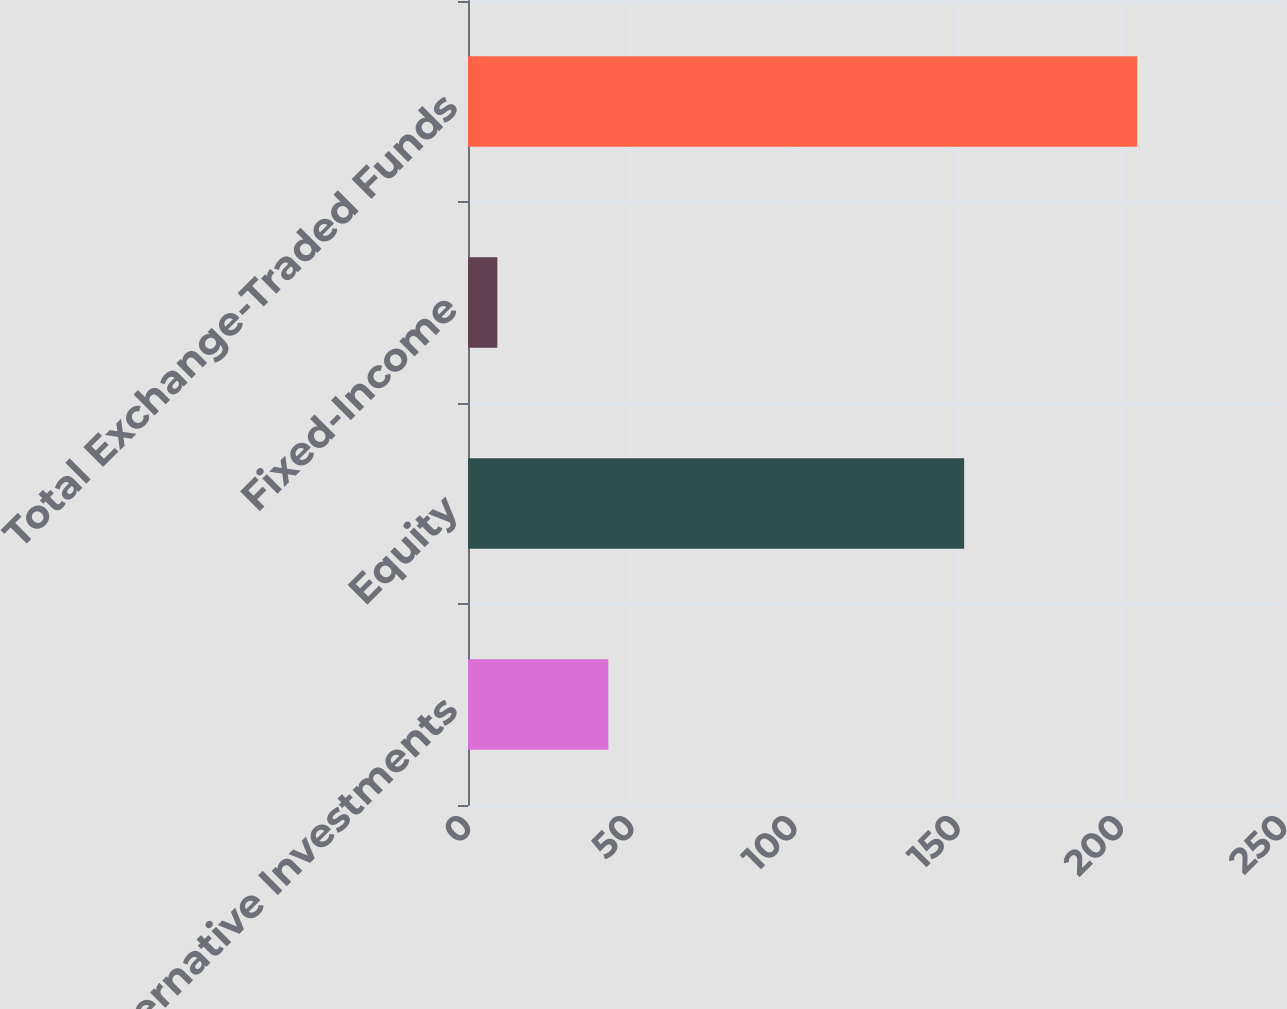Convert chart to OTSL. <chart><loc_0><loc_0><loc_500><loc_500><bar_chart><fcel>Alternative Investments<fcel>Equity<fcel>Fixed-Income<fcel>Total Exchange-Traded Funds<nl><fcel>43<fcel>152<fcel>9<fcel>205<nl></chart> 